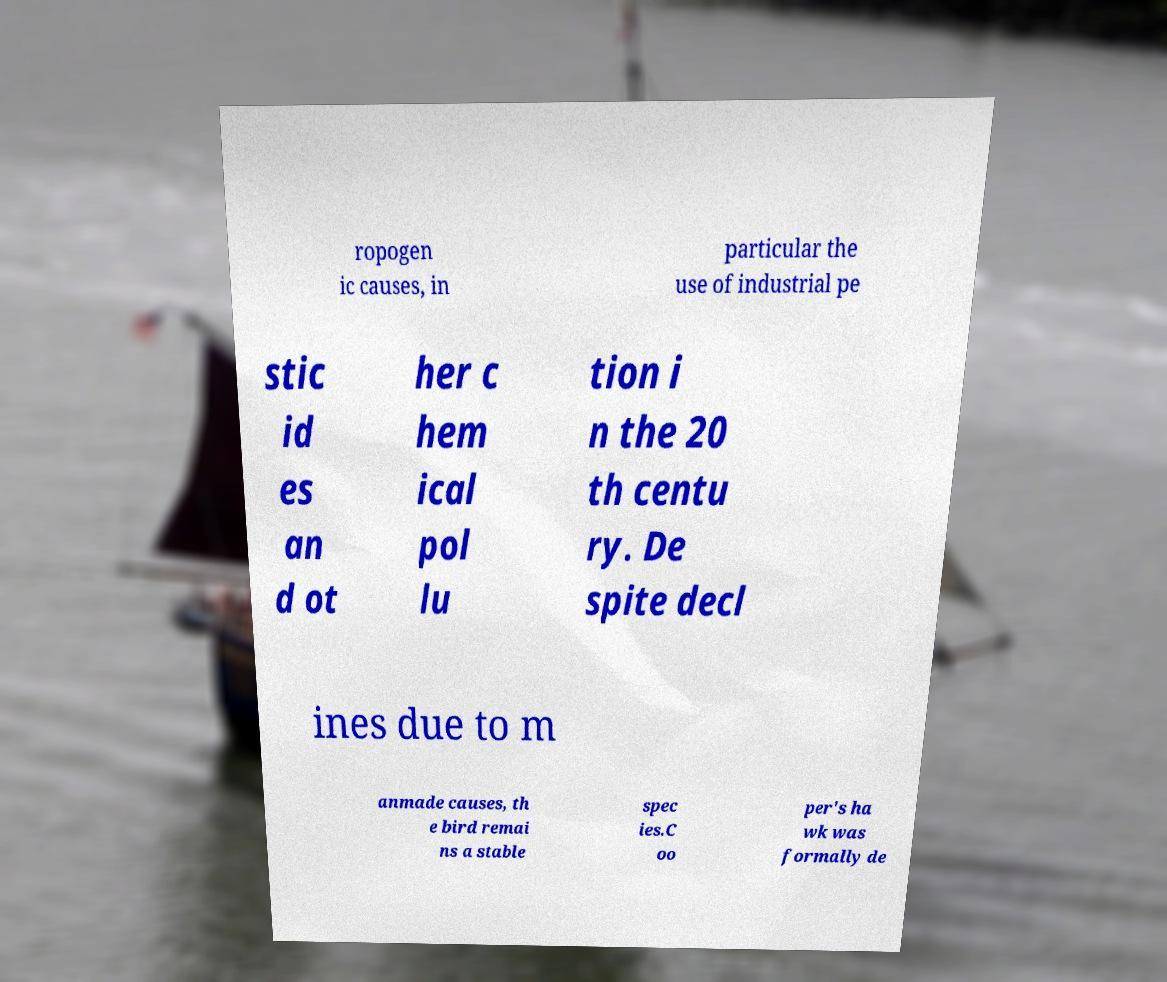Could you extract and type out the text from this image? ropogen ic causes, in particular the use of industrial pe stic id es an d ot her c hem ical pol lu tion i n the 20 th centu ry. De spite decl ines due to m anmade causes, th e bird remai ns a stable spec ies.C oo per's ha wk was formally de 